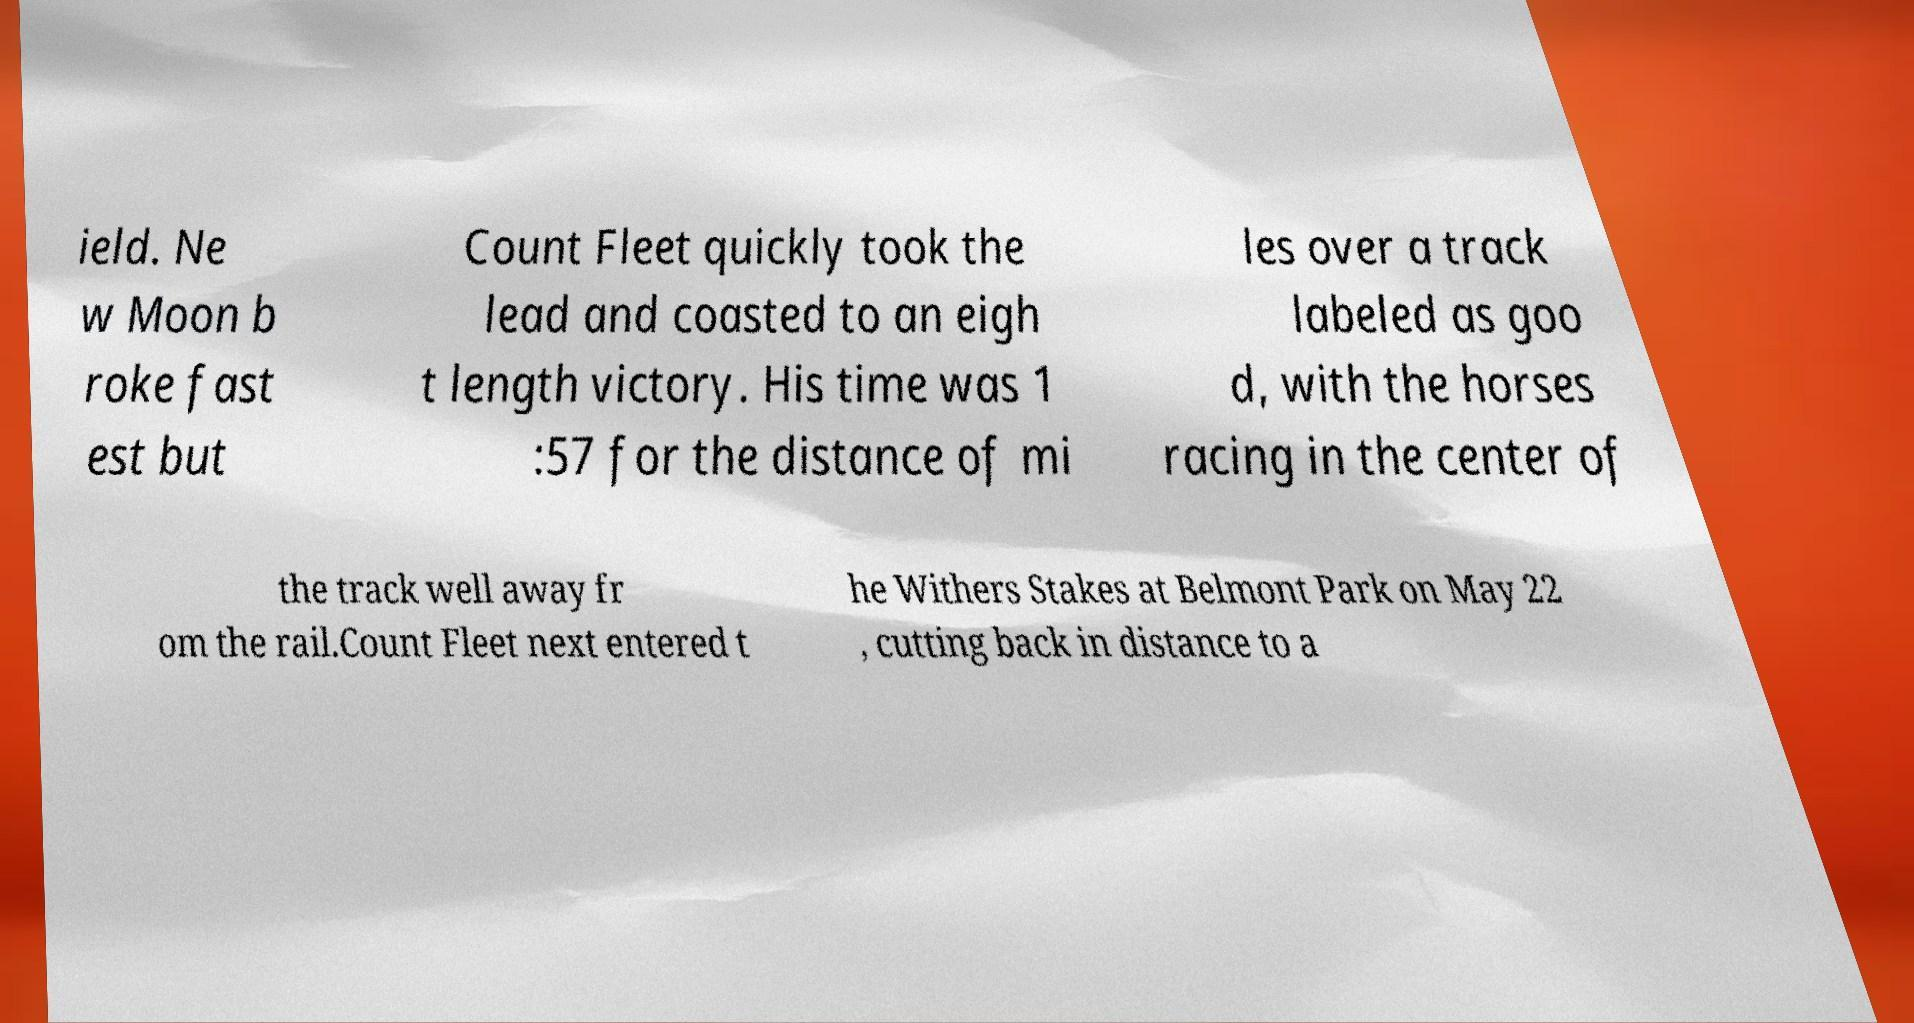Could you extract and type out the text from this image? ield. Ne w Moon b roke fast est but Count Fleet quickly took the lead and coasted to an eigh t length victory. His time was 1 :57 for the distance of mi les over a track labeled as goo d, with the horses racing in the center of the track well away fr om the rail.Count Fleet next entered t he Withers Stakes at Belmont Park on May 22 , cutting back in distance to a 